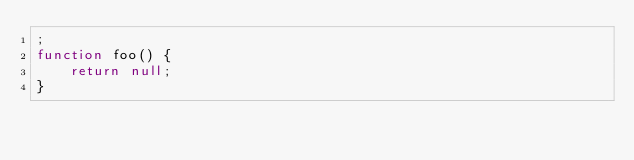Convert code to text. <code><loc_0><loc_0><loc_500><loc_500><_JavaScript_>;
function foo() {
    return null;
}
</code> 